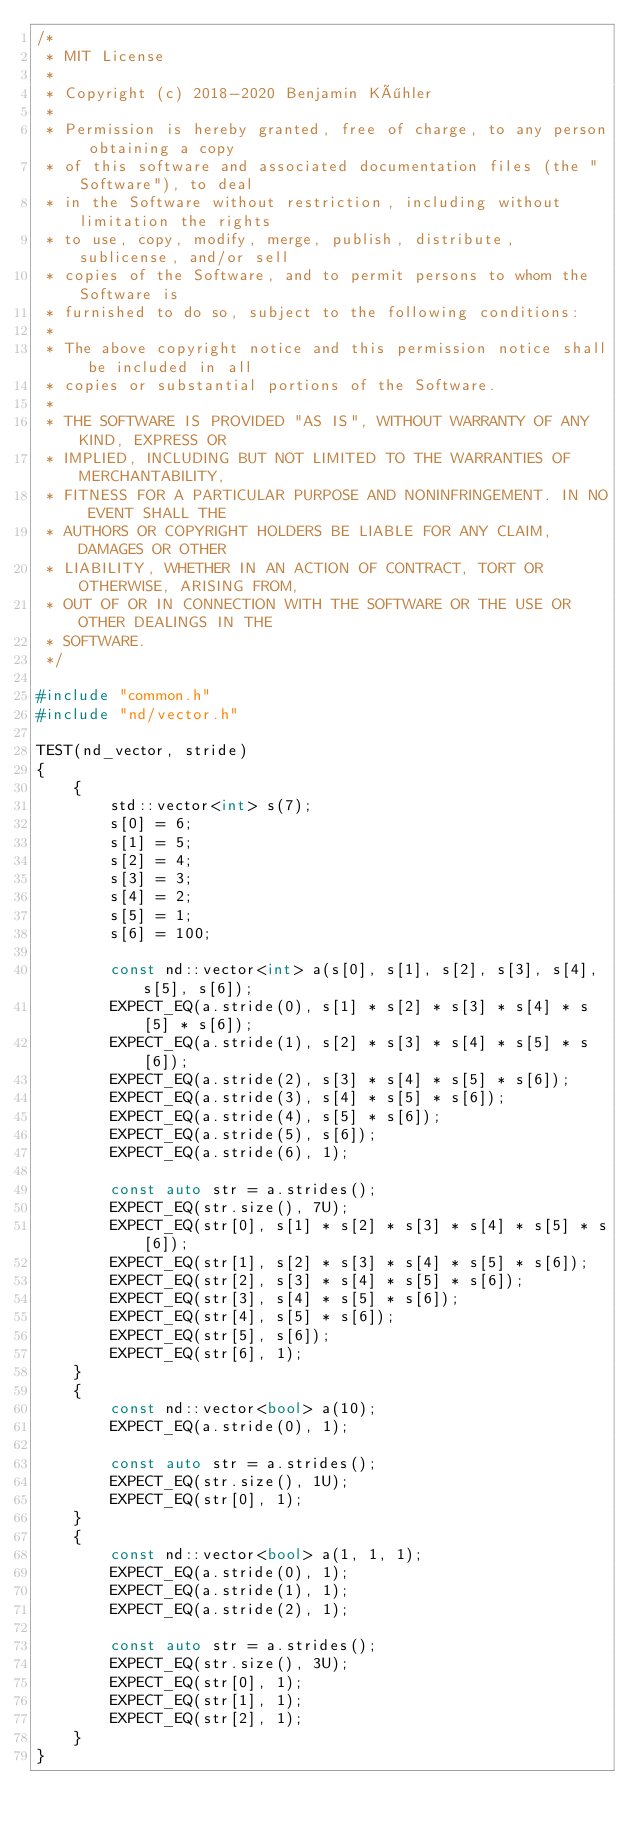<code> <loc_0><loc_0><loc_500><loc_500><_C++_>/*
 * MIT License
 *
 * Copyright (c) 2018-2020 Benjamin Köhler
 *
 * Permission is hereby granted, free of charge, to any person obtaining a copy
 * of this software and associated documentation files (the "Software"), to deal
 * in the Software without restriction, including without limitation the rights
 * to use, copy, modify, merge, publish, distribute, sublicense, and/or sell
 * copies of the Software, and to permit persons to whom the Software is
 * furnished to do so, subject to the following conditions:
 *
 * The above copyright notice and this permission notice shall be included in all
 * copies or substantial portions of the Software.
 *
 * THE SOFTWARE IS PROVIDED "AS IS", WITHOUT WARRANTY OF ANY KIND, EXPRESS OR
 * IMPLIED, INCLUDING BUT NOT LIMITED TO THE WARRANTIES OF MERCHANTABILITY,
 * FITNESS FOR A PARTICULAR PURPOSE AND NONINFRINGEMENT. IN NO EVENT SHALL THE
 * AUTHORS OR COPYRIGHT HOLDERS BE LIABLE FOR ANY CLAIM, DAMAGES OR OTHER
 * LIABILITY, WHETHER IN AN ACTION OF CONTRACT, TORT OR OTHERWISE, ARISING FROM,
 * OUT OF OR IN CONNECTION WITH THE SOFTWARE OR THE USE OR OTHER DEALINGS IN THE
 * SOFTWARE.
 */

#include "common.h"
#include "nd/vector.h"

TEST(nd_vector, stride)
{
    {
        std::vector<int> s(7);
        s[0] = 6;
        s[1] = 5;
        s[2] = 4;
        s[3] = 3;
        s[4] = 2;
        s[5] = 1;
        s[6] = 100;

        const nd::vector<int> a(s[0], s[1], s[2], s[3], s[4], s[5], s[6]);
        EXPECT_EQ(a.stride(0), s[1] * s[2] * s[3] * s[4] * s[5] * s[6]);
        EXPECT_EQ(a.stride(1), s[2] * s[3] * s[4] * s[5] * s[6]);
        EXPECT_EQ(a.stride(2), s[3] * s[4] * s[5] * s[6]);
        EXPECT_EQ(a.stride(3), s[4] * s[5] * s[6]);
        EXPECT_EQ(a.stride(4), s[5] * s[6]);
        EXPECT_EQ(a.stride(5), s[6]);
        EXPECT_EQ(a.stride(6), 1);

        const auto str = a.strides();
        EXPECT_EQ(str.size(), 7U);
        EXPECT_EQ(str[0], s[1] * s[2] * s[3] * s[4] * s[5] * s[6]);
        EXPECT_EQ(str[1], s[2] * s[3] * s[4] * s[5] * s[6]);
        EXPECT_EQ(str[2], s[3] * s[4] * s[5] * s[6]);
        EXPECT_EQ(str[3], s[4] * s[5] * s[6]);
        EXPECT_EQ(str[4], s[5] * s[6]);
        EXPECT_EQ(str[5], s[6]);
        EXPECT_EQ(str[6], 1);
    }
    {
        const nd::vector<bool> a(10);
        EXPECT_EQ(a.stride(0), 1);

        const auto str = a.strides();
        EXPECT_EQ(str.size(), 1U);
        EXPECT_EQ(str[0], 1);
    }
    {
        const nd::vector<bool> a(1, 1, 1);
        EXPECT_EQ(a.stride(0), 1);
        EXPECT_EQ(a.stride(1), 1);
        EXPECT_EQ(a.stride(2), 1);

        const auto str = a.strides();
        EXPECT_EQ(str.size(), 3U);
        EXPECT_EQ(str[0], 1);
        EXPECT_EQ(str[1], 1);
        EXPECT_EQ(str[2], 1);
    }
}
</code> 